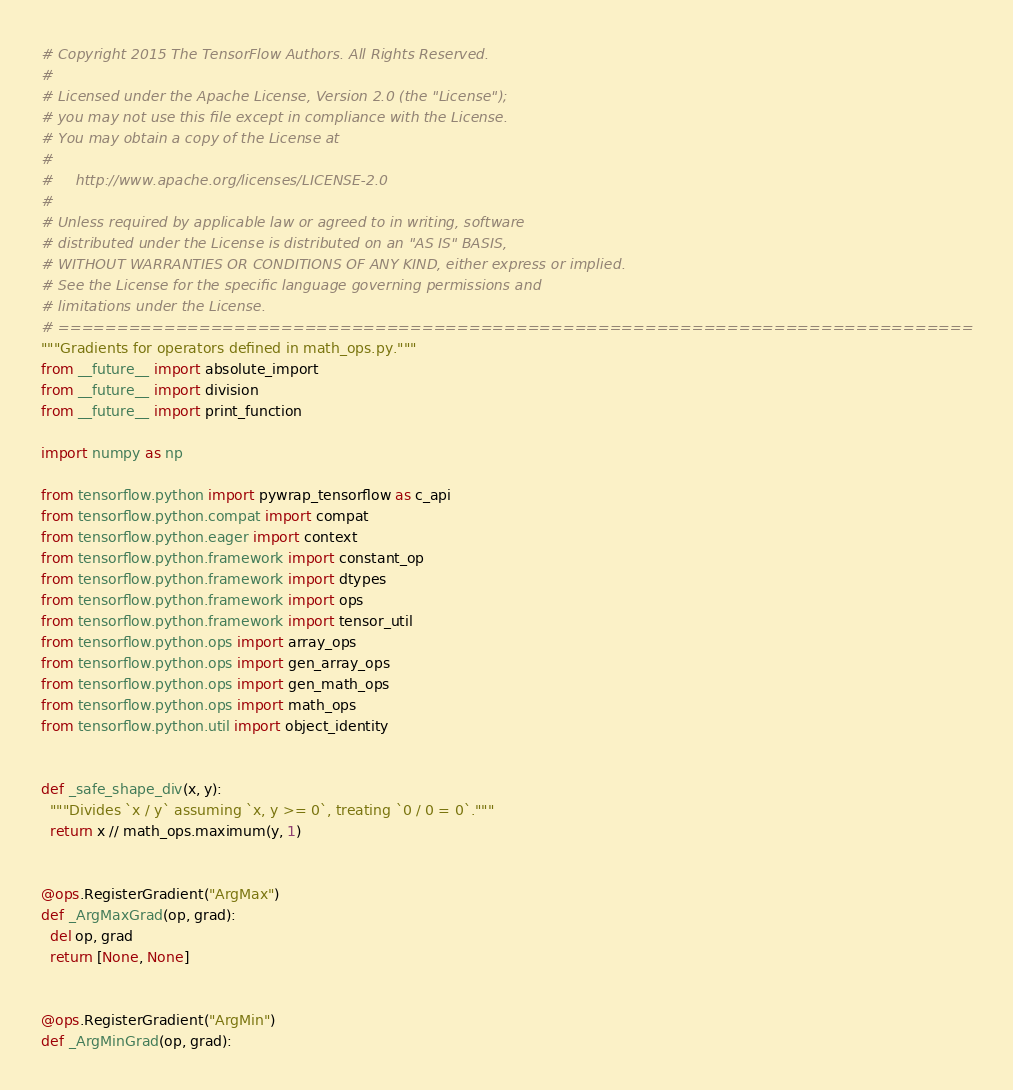<code> <loc_0><loc_0><loc_500><loc_500><_Python_># Copyright 2015 The TensorFlow Authors. All Rights Reserved.
#
# Licensed under the Apache License, Version 2.0 (the "License");
# you may not use this file except in compliance with the License.
# You may obtain a copy of the License at
#
#     http://www.apache.org/licenses/LICENSE-2.0
#
# Unless required by applicable law or agreed to in writing, software
# distributed under the License is distributed on an "AS IS" BASIS,
# WITHOUT WARRANTIES OR CONDITIONS OF ANY KIND, either express or implied.
# See the License for the specific language governing permissions and
# limitations under the License.
# ==============================================================================
"""Gradients for operators defined in math_ops.py."""
from __future__ import absolute_import
from __future__ import division
from __future__ import print_function

import numpy as np

from tensorflow.python import pywrap_tensorflow as c_api
from tensorflow.python.compat import compat
from tensorflow.python.eager import context
from tensorflow.python.framework import constant_op
from tensorflow.python.framework import dtypes
from tensorflow.python.framework import ops
from tensorflow.python.framework import tensor_util
from tensorflow.python.ops import array_ops
from tensorflow.python.ops import gen_array_ops
from tensorflow.python.ops import gen_math_ops
from tensorflow.python.ops import math_ops
from tensorflow.python.util import object_identity


def _safe_shape_div(x, y):
  """Divides `x / y` assuming `x, y >= 0`, treating `0 / 0 = 0`."""
  return x // math_ops.maximum(y, 1)


@ops.RegisterGradient("ArgMax")
def _ArgMaxGrad(op, grad):
  del op, grad
  return [None, None]


@ops.RegisterGradient("ArgMin")
def _ArgMinGrad(op, grad):</code> 